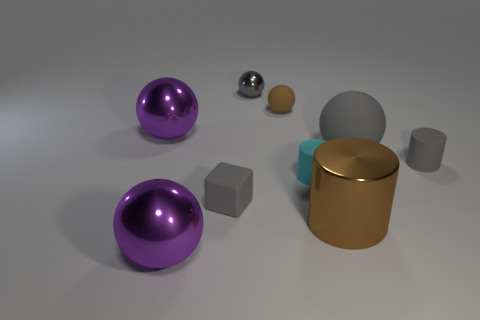There is a tiny sphere that is the same color as the big matte thing; what is it made of?
Offer a terse response. Metal. How many matte blocks are on the right side of the tiny brown object?
Keep it short and to the point. 0. Are there any tiny gray cylinders made of the same material as the cube?
Offer a very short reply. Yes. What is the material of the gray sphere that is the same size as the cyan matte cylinder?
Offer a very short reply. Metal. Are the block and the big brown cylinder made of the same material?
Your answer should be very brief. No. What number of objects are either tiny brown matte spheres or purple objects?
Your answer should be compact. 3. What is the shape of the small gray object that is to the right of the small gray metallic thing?
Offer a terse response. Cylinder. There is a cylinder that is made of the same material as the tiny gray ball; what color is it?
Make the answer very short. Brown. What is the material of the other gray thing that is the same shape as the large gray object?
Ensure brevity in your answer.  Metal. There is a brown rubber thing; what shape is it?
Provide a short and direct response. Sphere. 